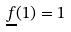<formula> <loc_0><loc_0><loc_500><loc_500>\underline { f } ( 1 ) = 1</formula> 